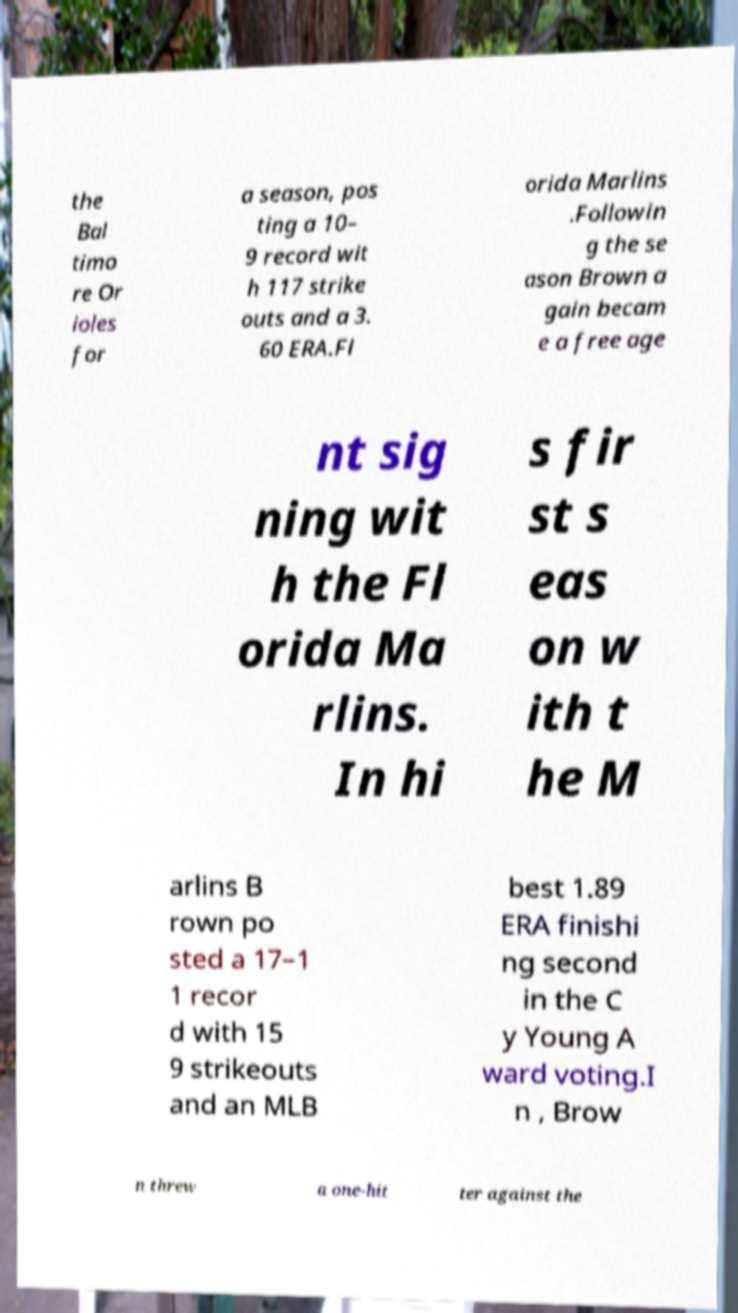Can you read and provide the text displayed in the image?This photo seems to have some interesting text. Can you extract and type it out for me? the Bal timo re Or ioles for a season, pos ting a 10– 9 record wit h 117 strike outs and a 3. 60 ERA.Fl orida Marlins .Followin g the se ason Brown a gain becam e a free age nt sig ning wit h the Fl orida Ma rlins. In hi s fir st s eas on w ith t he M arlins B rown po sted a 17–1 1 recor d with 15 9 strikeouts and an MLB best 1.89 ERA finishi ng second in the C y Young A ward voting.I n , Brow n threw a one-hit ter against the 